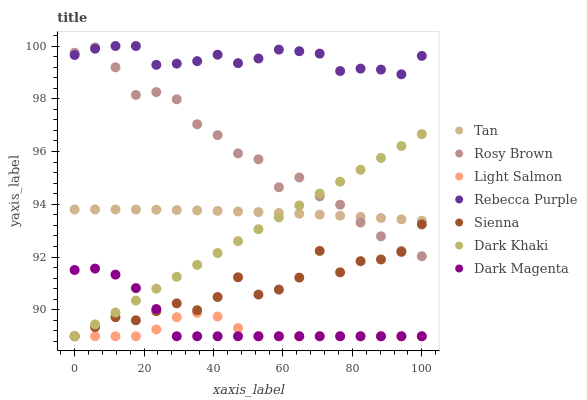Does Light Salmon have the minimum area under the curve?
Answer yes or no. Yes. Does Rebecca Purple have the maximum area under the curve?
Answer yes or no. Yes. Does Dark Magenta have the minimum area under the curve?
Answer yes or no. No. Does Dark Magenta have the maximum area under the curve?
Answer yes or no. No. Is Dark Khaki the smoothest?
Answer yes or no. Yes. Is Sienna the roughest?
Answer yes or no. Yes. Is Light Salmon the smoothest?
Answer yes or no. No. Is Light Salmon the roughest?
Answer yes or no. No. Does Dark Khaki have the lowest value?
Answer yes or no. Yes. Does Rosy Brown have the lowest value?
Answer yes or no. No. Does Rebecca Purple have the highest value?
Answer yes or no. Yes. Does Dark Magenta have the highest value?
Answer yes or no. No. Is Sienna less than Tan?
Answer yes or no. Yes. Is Tan greater than Dark Magenta?
Answer yes or no. Yes. Does Light Salmon intersect Sienna?
Answer yes or no. Yes. Is Light Salmon less than Sienna?
Answer yes or no. No. Is Light Salmon greater than Sienna?
Answer yes or no. No. Does Sienna intersect Tan?
Answer yes or no. No. 